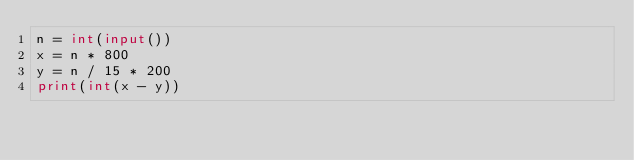<code> <loc_0><loc_0><loc_500><loc_500><_Python_>n = int(input())
x = n * 800
y = n / 15 * 200
print(int(x - y))</code> 